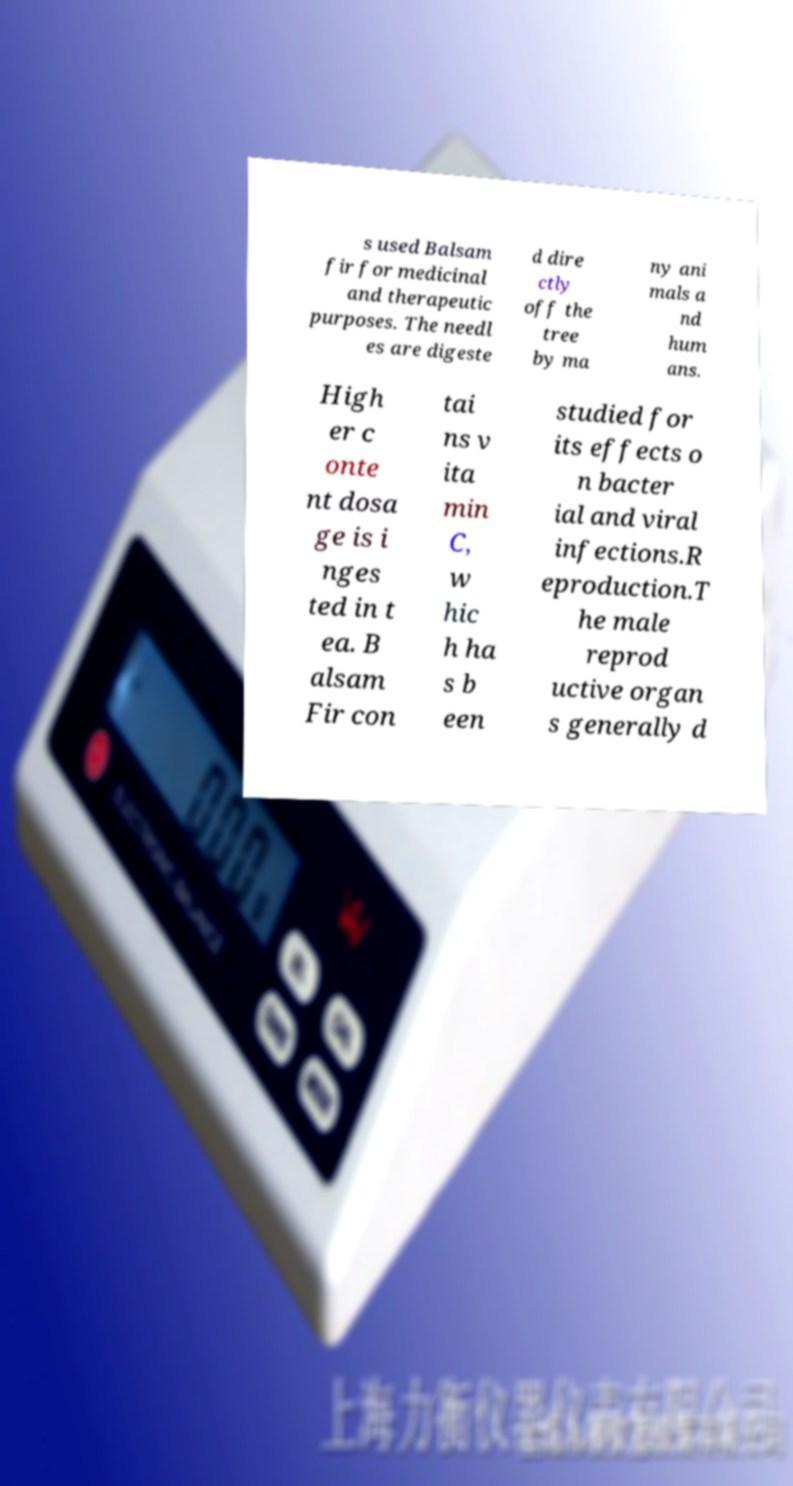Please read and relay the text visible in this image. What does it say? s used Balsam fir for medicinal and therapeutic purposes. The needl es are digeste d dire ctly off the tree by ma ny ani mals a nd hum ans. High er c onte nt dosa ge is i nges ted in t ea. B alsam Fir con tai ns v ita min C, w hic h ha s b een studied for its effects o n bacter ial and viral infections.R eproduction.T he male reprod uctive organ s generally d 